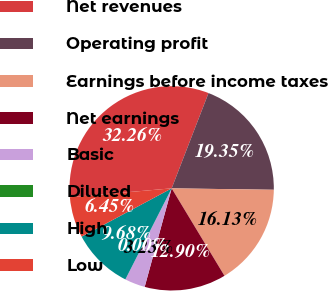Convert chart. <chart><loc_0><loc_0><loc_500><loc_500><pie_chart><fcel>Net revenues<fcel>Operating profit<fcel>Earnings before income taxes<fcel>Net earnings<fcel>Basic<fcel>Diluted<fcel>High<fcel>Low<nl><fcel>32.26%<fcel>19.35%<fcel>16.13%<fcel>12.9%<fcel>3.23%<fcel>0.0%<fcel>9.68%<fcel>6.45%<nl></chart> 